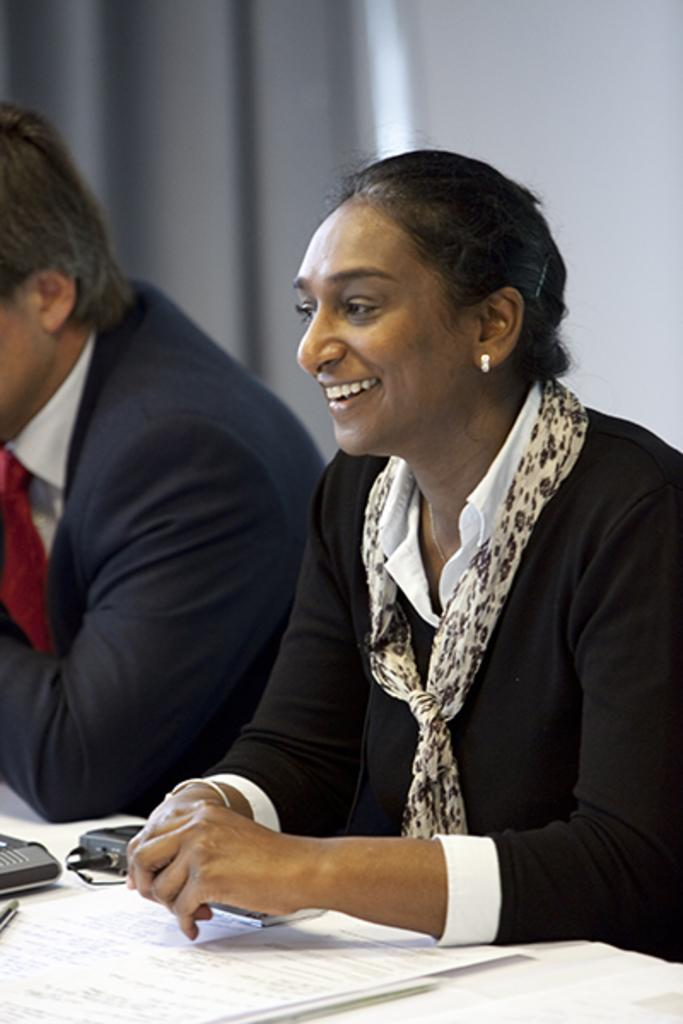How many people are sitting in the image? There are two people sitting in the image. What are the people wearing? The people are wearing different color dresses. What can be seen on the table or surface in front of the people? There are papers visible in the image. What else is present in the image besides the people and papers? There are objects present in the image. What is the color scheme of the background in the image? The background of the image is grey and white. What type of van can be seen driving through the door in the image? There is no van or door present in the image; it features two people sitting and wearing different color dresses, with papers and other objects visible. 